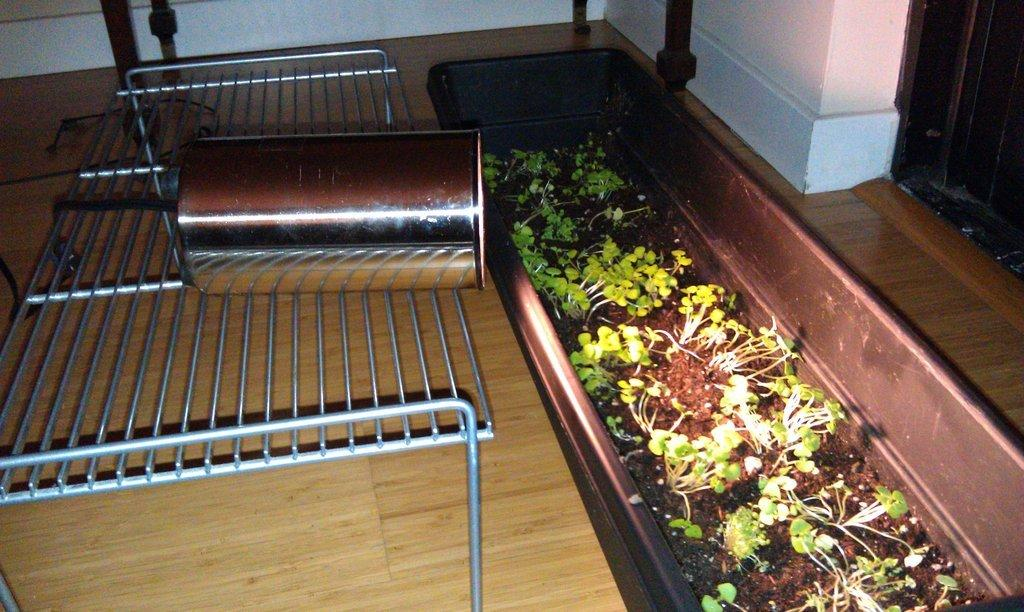What is located in the center of the image? There are grills, a tin, and a pot containing plants in the center of the image. What is inside the tin in the image? The facts provided do not specify what is inside the tin. What type of plants are in the pot in the image? The facts provided do not specify the type of plants in the pot. What is visible at the top of the image? There is a wall at the top of the image. What can be seen in the background of the image? The floor is visible in the background of the image. Can you see any toes in the image? There are no toes visible in the image. Are there any goldfish swimming in the pot with the plants? There are no goldfish present in the image; it contains only plants. 